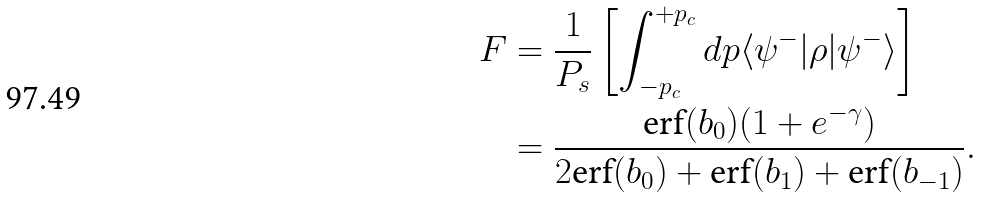Convert formula to latex. <formula><loc_0><loc_0><loc_500><loc_500>F & = \frac { 1 } { P _ { s } } \left [ \int _ { - p _ { c } } ^ { + p _ { c } } d p \langle \psi ^ { - } | \rho | \psi ^ { - } \rangle \right ] \\ & = \frac { \text {erf} ( b _ { 0 } ) ( 1 + e ^ { - \gamma } ) } { 2 \text {erf} ( b _ { 0 } ) + \text {erf} ( b _ { 1 } ) + \text {erf} ( b _ { - 1 } ) } .</formula> 